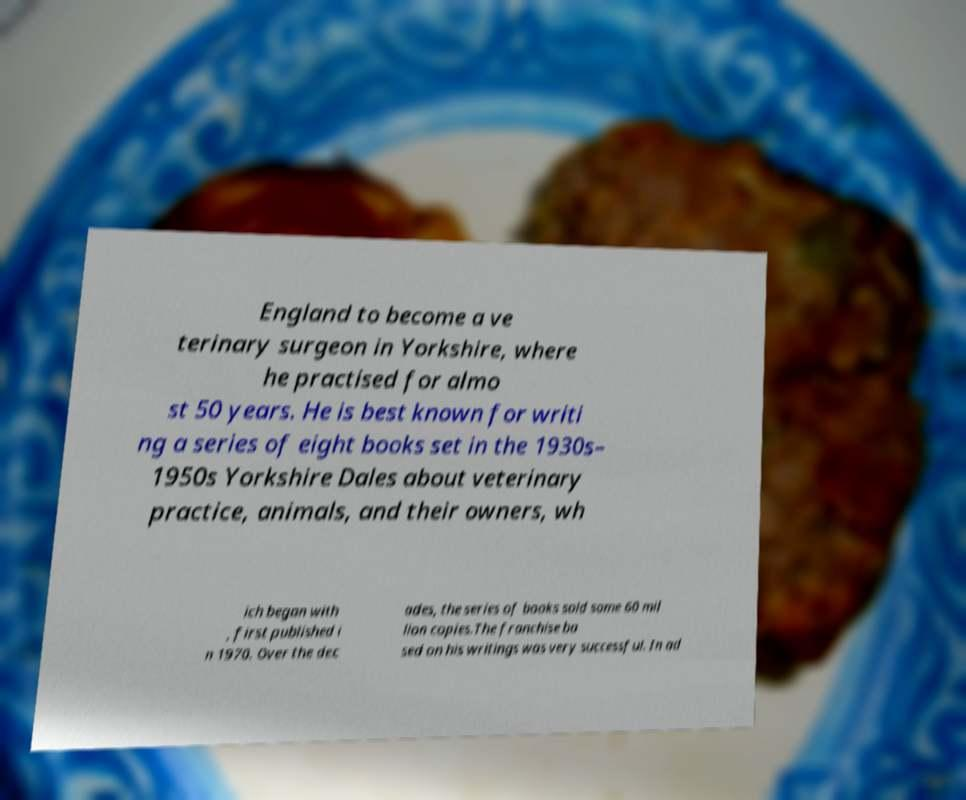Please read and relay the text visible in this image. What does it say? England to become a ve terinary surgeon in Yorkshire, where he practised for almo st 50 years. He is best known for writi ng a series of eight books set in the 1930s– 1950s Yorkshire Dales about veterinary practice, animals, and their owners, wh ich began with , first published i n 1970. Over the dec ades, the series of books sold some 60 mil lion copies.The franchise ba sed on his writings was very successful. In ad 